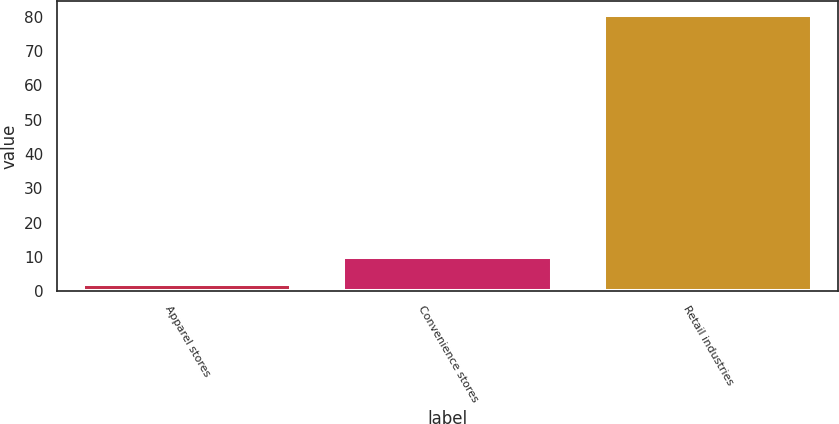<chart> <loc_0><loc_0><loc_500><loc_500><bar_chart><fcel>Apparel stores<fcel>Convenience stores<fcel>Retail industries<nl><fcel>2<fcel>10.1<fcel>80.4<nl></chart> 